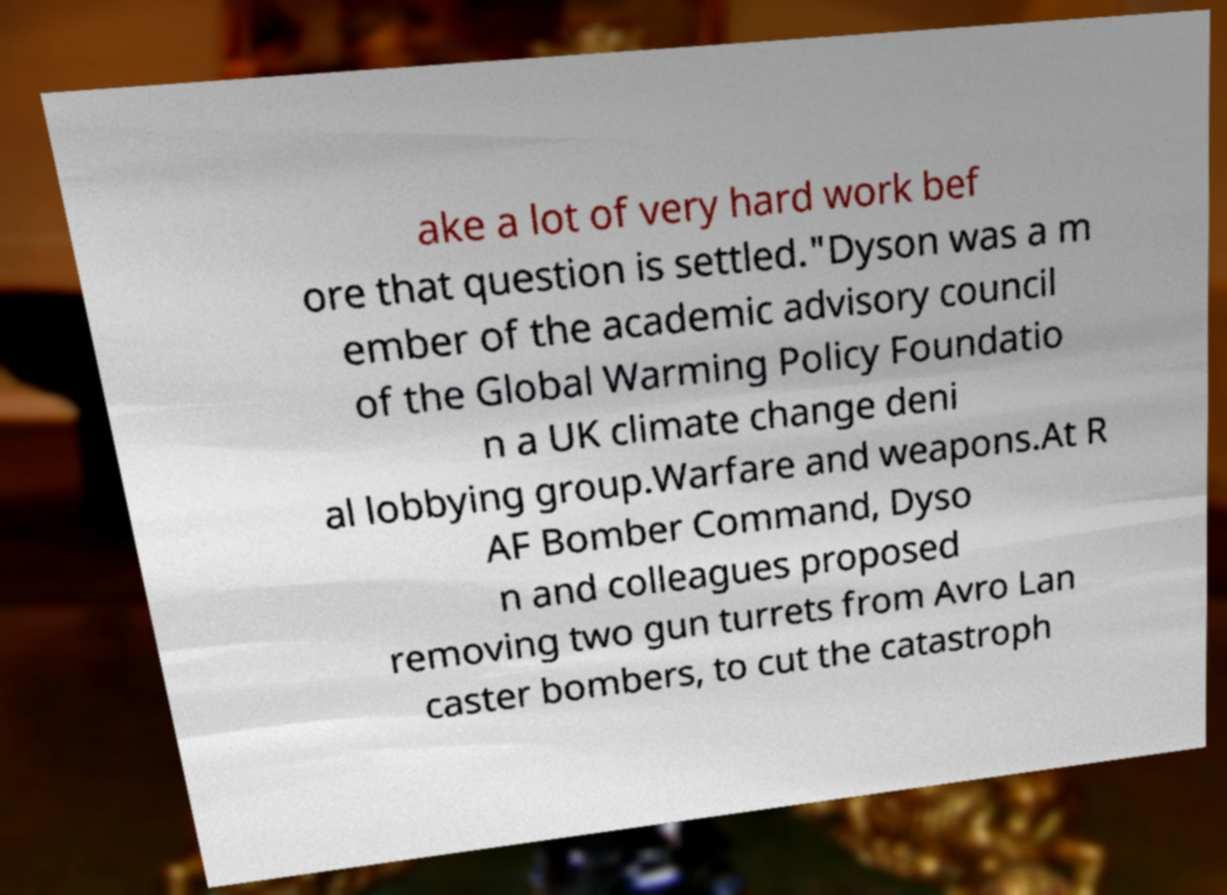Please identify and transcribe the text found in this image. ake a lot of very hard work bef ore that question is settled."Dyson was a m ember of the academic advisory council of the Global Warming Policy Foundatio n a UK climate change deni al lobbying group.Warfare and weapons.At R AF Bomber Command, Dyso n and colleagues proposed removing two gun turrets from Avro Lan caster bombers, to cut the catastroph 